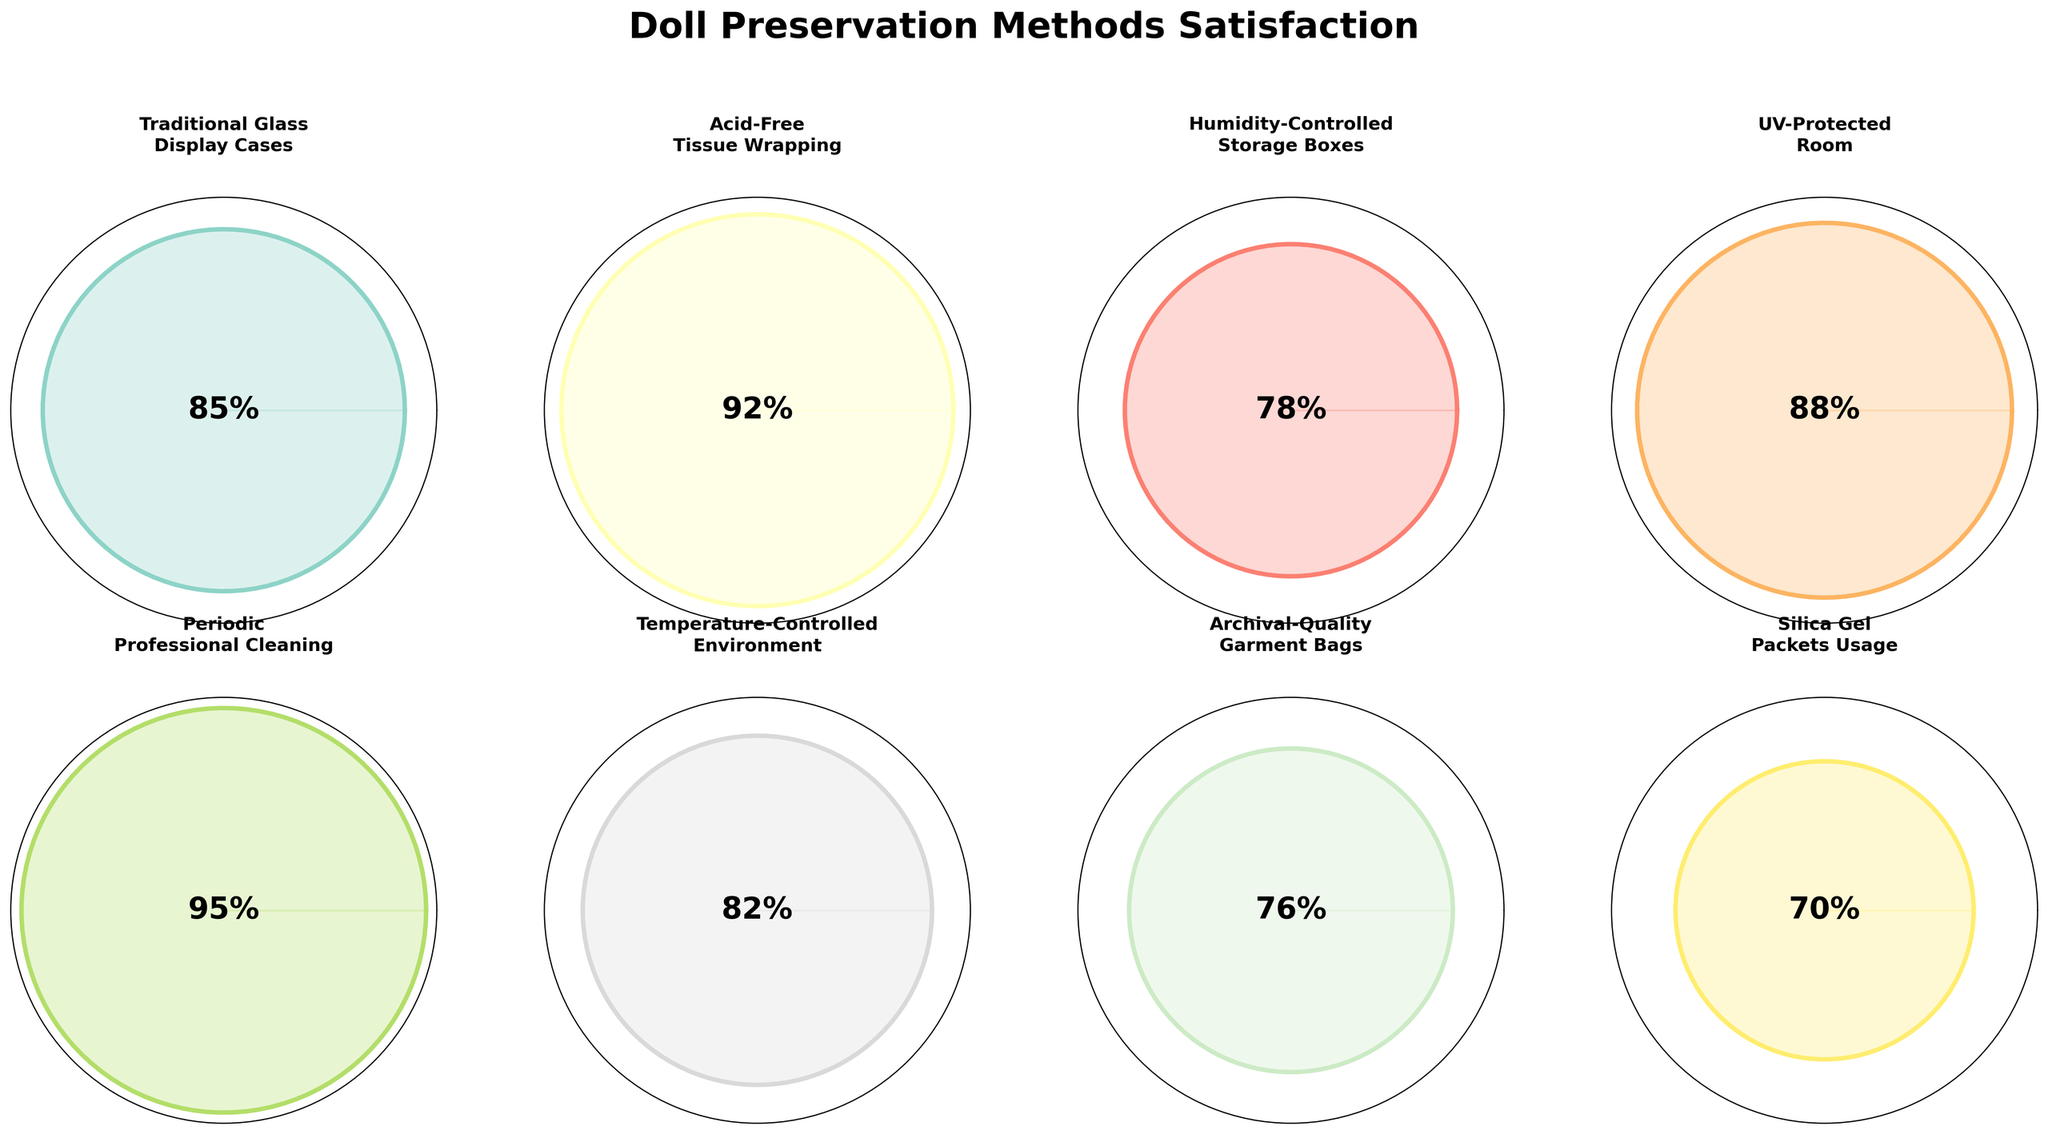what is the satisfaction percentage for "Periodic Professional Cleaning"? The satisfaction percentage for "Periodic Professional Cleaning" is represented clearly on the gauge chart with the value marked at the center of the plot.
Answer: 95% Which preservation method has the lowest satisfaction level? By examining the gauge charts, the satisfaction levels are displayed at the center of each plot. "Silica Gel Packets Usage" has the lowest satisfaction level at 70%.
Answer: Silica Gel Packets Usage What is the total satisfaction value for "Humidity-Controlled Storage Boxes" and "Archival-Quality Garment Bags"? "Humidity-Controlled Storage Boxes" has a satisfaction value of 78%, and "Archival-Quality Garment Bags" has a value of 76%. Adding these together: 78 + 76 = 154
Answer: 154 How many preservation methods have a satisfaction level above 80%? By looking at the satisfaction values at the center of each gauge chart, count the methods with values above 80%: "Traditional Glass Display Cases" (85%), "Acid-Free Tissue Wrapping" (92%), "UV-Protected Room" (88%), "Periodic Professional Cleaning" (95%), and "Temperature-Controlled Environment" (82%). There are 5 such methods.
Answer: 5 Which preservation method ranks mid-way in satisfaction level? Arrange the satisfaction levels in ascending order: 70, 76, 78, 82, 85, 88, 92, 95. The mid-way values are 82 and 85. The "Temperature-Controlled Environment" ranks mid-way, just slightly lower than "Traditional Glass Display Cases."
Answer: Temperature-Controlled Environment What is the average satisfaction level of all the preservation methods? Sum all satisfaction values: 85 + 92 + 78 + 88 + 95 + 82 + 76 + 70 = 666. Divide the total by the number of methods: 666 / 8 = 83.25
Answer: 83.25 Between "Traditional Glass Display Cases" and "UV-Protected Room," which one has a higher satisfaction level and by how much? "Traditional Glass Display Cases" has a satisfaction level of 85%, "UV-Protected Room" has 88%. The difference: 88 - 85 = 3%.
Answer: UV-Protected Room, by 3% Which two methods have the highest and second highest satisfaction levels? By examining the satisfaction percentages displayed, "Periodic Professional Cleaning" has the highest level at 95%, followed by "Acid-Free Tissue Wrapping" at 92%.
Answer: Periodic Professional Cleaning and Acid-Free Tissue Wrapping 